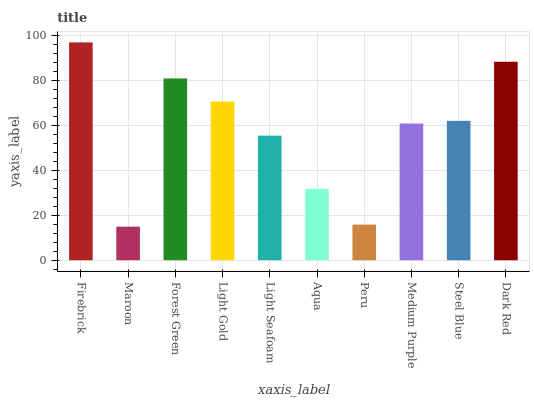Is Maroon the minimum?
Answer yes or no. Yes. Is Firebrick the maximum?
Answer yes or no. Yes. Is Forest Green the minimum?
Answer yes or no. No. Is Forest Green the maximum?
Answer yes or no. No. Is Forest Green greater than Maroon?
Answer yes or no. Yes. Is Maroon less than Forest Green?
Answer yes or no. Yes. Is Maroon greater than Forest Green?
Answer yes or no. No. Is Forest Green less than Maroon?
Answer yes or no. No. Is Steel Blue the high median?
Answer yes or no. Yes. Is Medium Purple the low median?
Answer yes or no. Yes. Is Maroon the high median?
Answer yes or no. No. Is Steel Blue the low median?
Answer yes or no. No. 